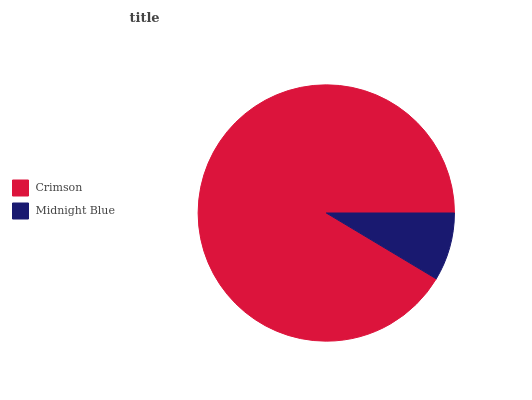Is Midnight Blue the minimum?
Answer yes or no. Yes. Is Crimson the maximum?
Answer yes or no. Yes. Is Midnight Blue the maximum?
Answer yes or no. No. Is Crimson greater than Midnight Blue?
Answer yes or no. Yes. Is Midnight Blue less than Crimson?
Answer yes or no. Yes. Is Midnight Blue greater than Crimson?
Answer yes or no. No. Is Crimson less than Midnight Blue?
Answer yes or no. No. Is Crimson the high median?
Answer yes or no. Yes. Is Midnight Blue the low median?
Answer yes or no. Yes. Is Midnight Blue the high median?
Answer yes or no. No. Is Crimson the low median?
Answer yes or no. No. 